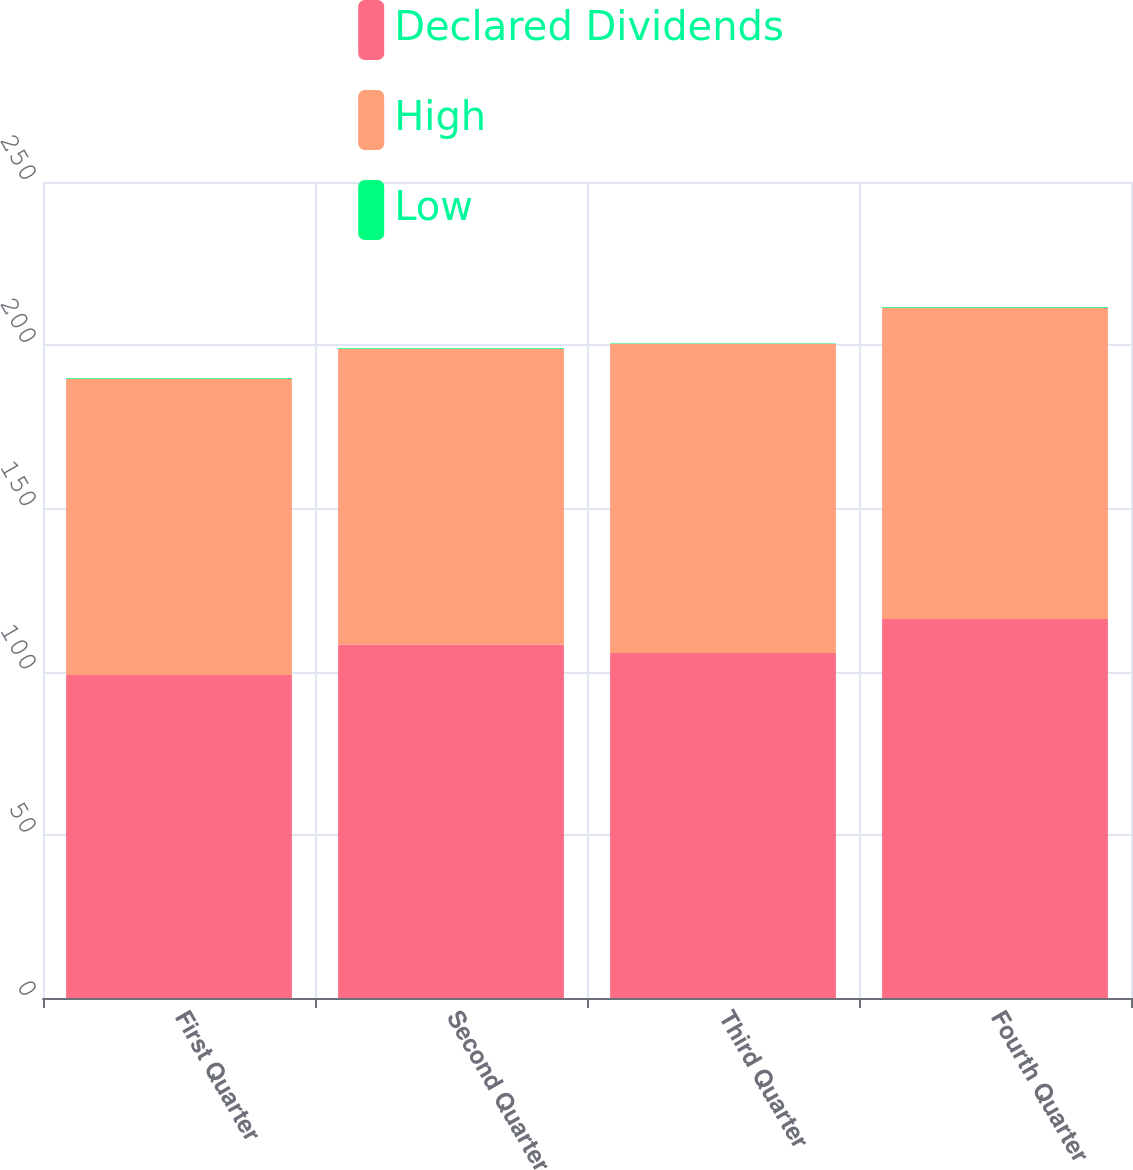Convert chart to OTSL. <chart><loc_0><loc_0><loc_500><loc_500><stacked_bar_chart><ecel><fcel>First Quarter<fcel>Second Quarter<fcel>Third Quarter<fcel>Fourth Quarter<nl><fcel>Declared Dividends<fcel>98.95<fcel>108.33<fcel>105.68<fcel>116.14<nl><fcel>High<fcel>90.77<fcel>90.48<fcel>94.73<fcel>95.33<nl><fcel>Low<fcel>0.22<fcel>0.22<fcel>0.22<fcel>0.22<nl></chart> 